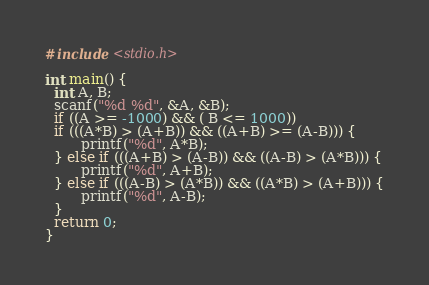<code> <loc_0><loc_0><loc_500><loc_500><_C_>#include <stdio.h>

int main() {
  int A, B;
  scanf("%d %d", &A, &B);
  if ((A >= -1000) && ( B <= 1000))
  if (((A*B) > (A+B)) && ((A+B) >= (A-B))) {
    	printf("%d", A*B);
  } else if (((A+B) > (A-B)) && ((A-B) > (A*B))) {
    	printf("%d", A+B);
  } else if (((A-B) > (A*B)) && ((A*B) > (A+B))) {
    	printf("%d", A-B);
  }
  return 0;
}
</code> 